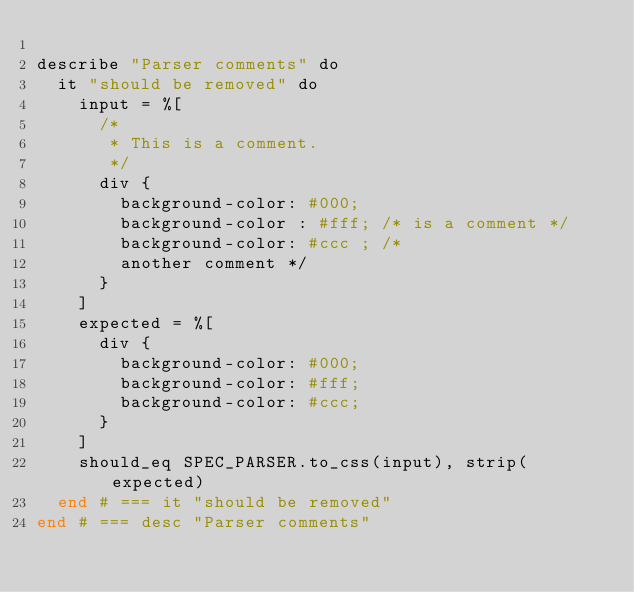<code> <loc_0><loc_0><loc_500><loc_500><_Crystal_>
describe "Parser comments" do
  it "should be removed" do
    input = %[
      /*
       * This is a comment.
       */
      div {
        background-color: #000;
        background-color : #fff; /* is a comment */
        background-color: #ccc ; /*
        another comment */
      }
    ]
    expected = %[
      div {
        background-color: #000;
        background-color: #fff;
        background-color: #ccc;
      }
    ]
    should_eq SPEC_PARSER.to_css(input), strip(expected)
  end # === it "should be removed"
end # === desc "Parser comments"
</code> 